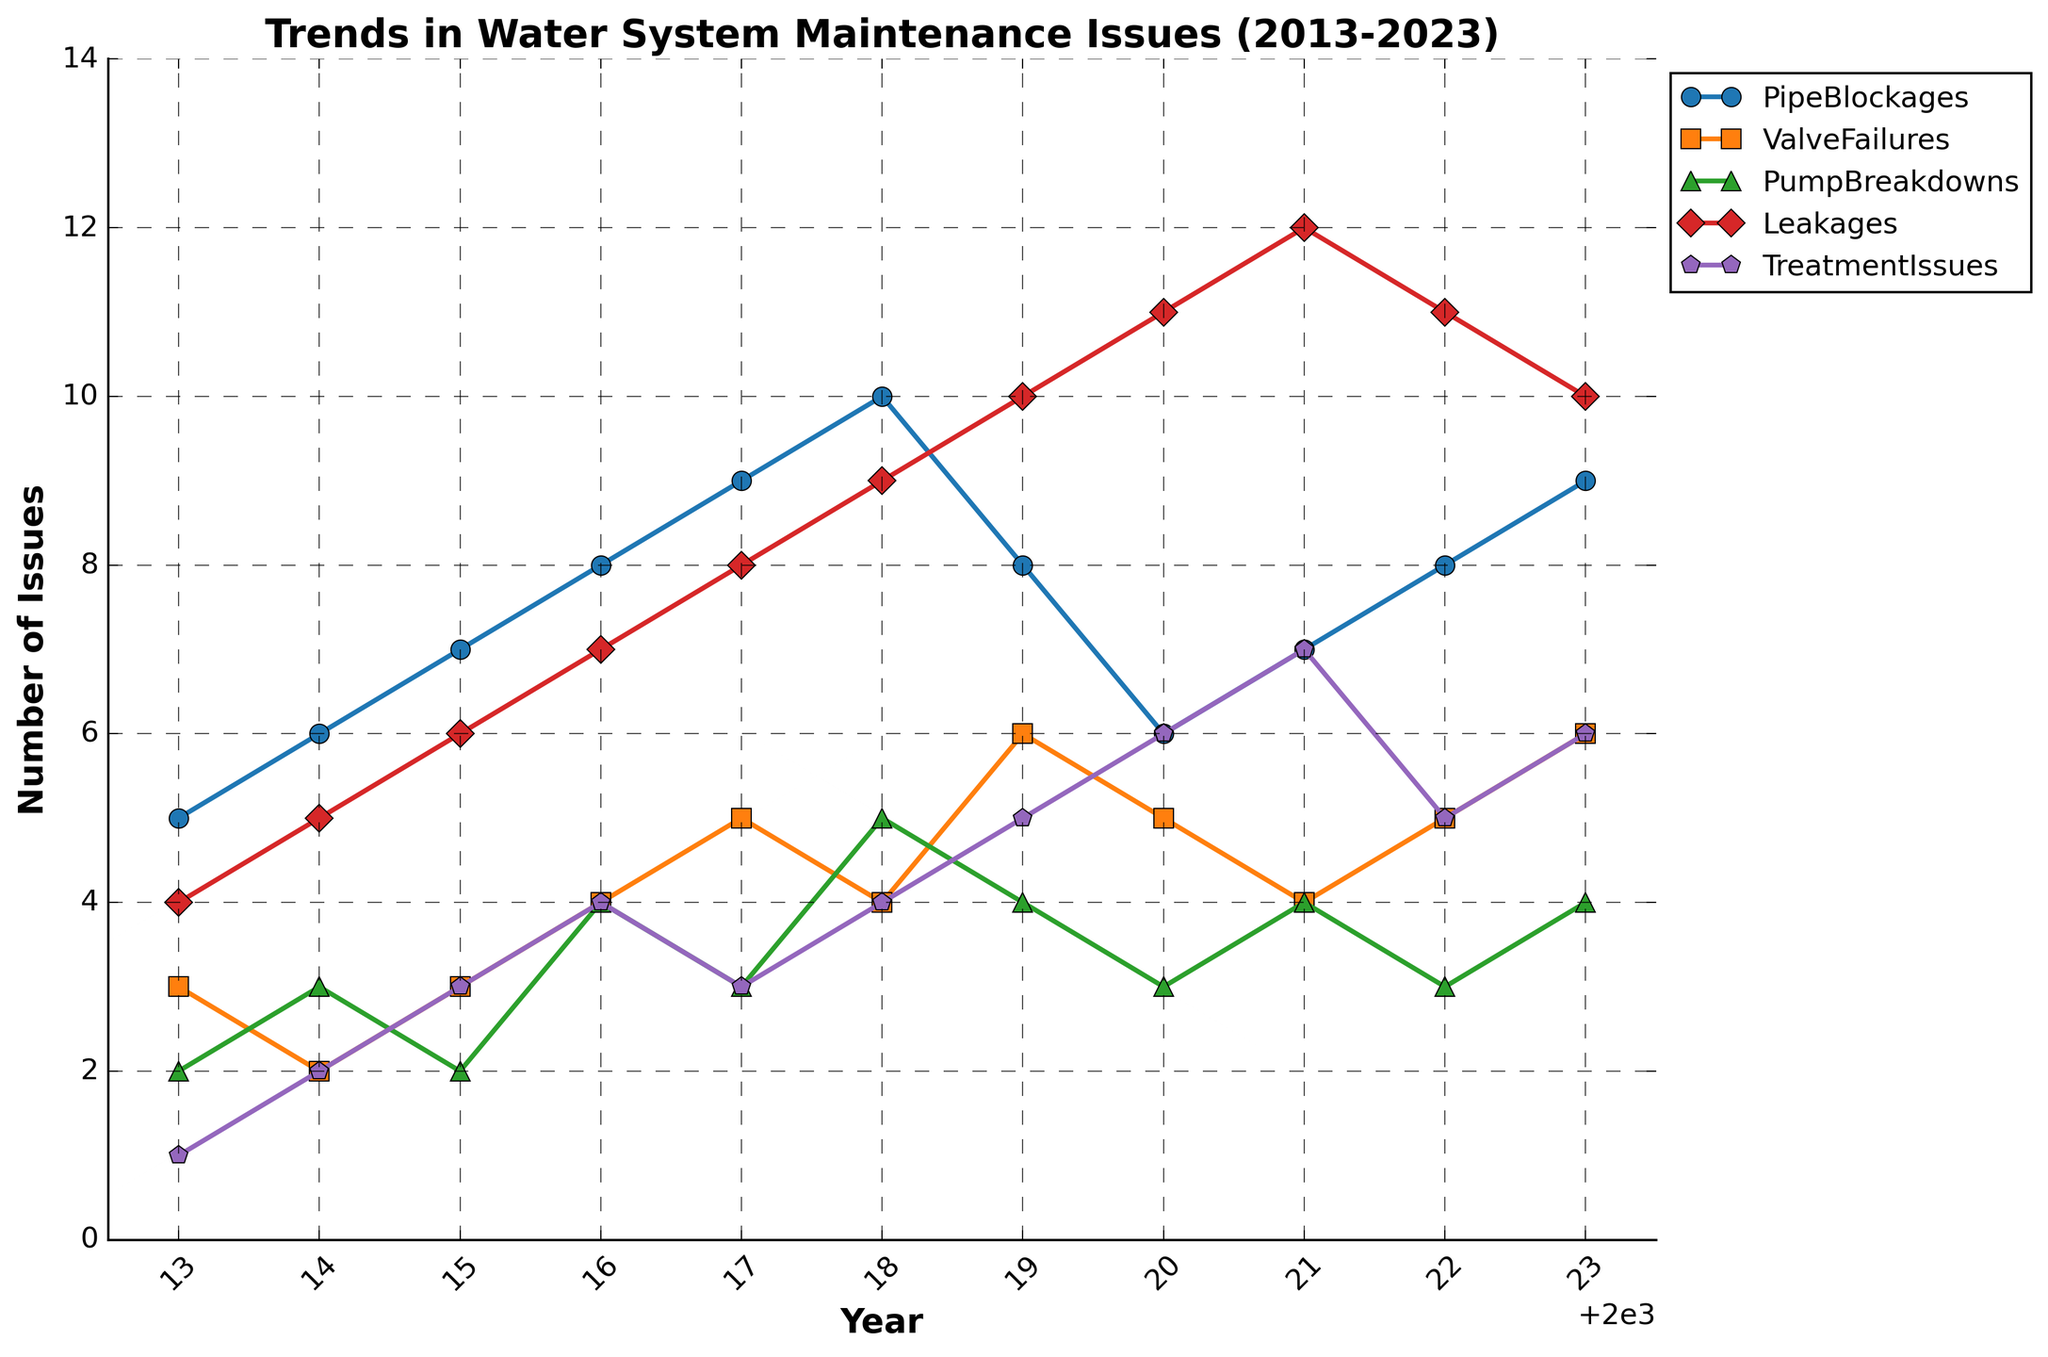What is the title of the figure? The title of the figure is generally located at the top and it provides an overview of what the graphic represents.
Answer: Trends in Water System Maintenance Issues (2013-2023) Which type of water system issue had the highest number recorded in a single year? Look at the peaks of each time series and identify the highest point among all the issues. The issue with the highest peak is the answer.
Answer: Leakages How many times did Valve Failures occur in 2017? Find the data point on the Valve Failures line plot corresponding with the year 2017.
Answer: 5 Between which two consecutive years did Pump Breakdowns increase the most? Check the Pump Breakdowns line plot for the largest positive vertical change between two consecutive years.
Answer: 2017 to 2018 Did the number of Pipe Blockages increase, decrease, or remain the same from 2019 to 2020? Find the value of Pipe Blockages in both years and compare them.
Answer: Decrease Which year shows the highest number of Treatment Issues? Find the peak point on the Treatment Issues line plot.
Answer: 2021 In which year did Leakages surpass 10 incidents? Find the first year in the Leakages line plot where the value goes above 10.
Answer: 2019 What is the average number of Pump Breakdowns from 2013 to 2023? Sum all the values for Pump Breakdowns and divide by the number of years (11).
Answer: 3.36 Compare the number of issues between Valve Failures and Treatment Issues in 2022. Which had more incidents? Find the values for Valve Failures and Treatment Issues in 2022 and compare them.
Answer: Valve Failures How many different types of water system issues are tracked in the figure? Count the different lines representing each issue in the plot.
Answer: 5 